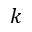<formula> <loc_0><loc_0><loc_500><loc_500>k</formula> 